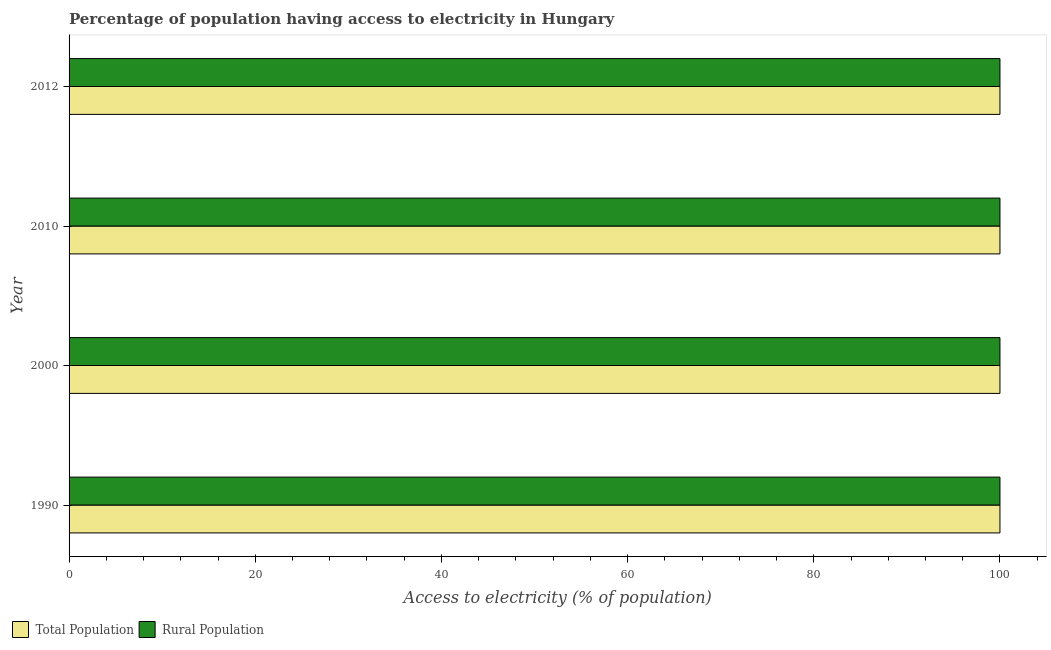How many different coloured bars are there?
Keep it short and to the point. 2. Are the number of bars on each tick of the Y-axis equal?
Offer a very short reply. Yes. How many bars are there on the 1st tick from the top?
Provide a short and direct response. 2. How many bars are there on the 2nd tick from the bottom?
Your answer should be compact. 2. What is the percentage of rural population having access to electricity in 2012?
Your answer should be very brief. 100. Across all years, what is the maximum percentage of population having access to electricity?
Provide a short and direct response. 100. Across all years, what is the minimum percentage of rural population having access to electricity?
Offer a very short reply. 100. In which year was the percentage of rural population having access to electricity maximum?
Your response must be concise. 1990. In which year was the percentage of rural population having access to electricity minimum?
Offer a very short reply. 1990. What is the total percentage of rural population having access to electricity in the graph?
Your answer should be very brief. 400. What is the difference between the percentage of rural population having access to electricity in 2010 and that in 2012?
Your answer should be very brief. 0. What is the difference between the percentage of population having access to electricity in 2010 and the percentage of rural population having access to electricity in 1990?
Provide a succinct answer. 0. What is the average percentage of rural population having access to electricity per year?
Offer a very short reply. 100. In the year 2012, what is the difference between the percentage of population having access to electricity and percentage of rural population having access to electricity?
Offer a very short reply. 0. What is the ratio of the percentage of rural population having access to electricity in 2000 to that in 2012?
Offer a terse response. 1. Is the difference between the percentage of population having access to electricity in 2010 and 2012 greater than the difference between the percentage of rural population having access to electricity in 2010 and 2012?
Make the answer very short. No. In how many years, is the percentage of population having access to electricity greater than the average percentage of population having access to electricity taken over all years?
Offer a very short reply. 0. What does the 2nd bar from the top in 2012 represents?
Keep it short and to the point. Total Population. What does the 2nd bar from the bottom in 2012 represents?
Give a very brief answer. Rural Population. How many bars are there?
Keep it short and to the point. 8. Are all the bars in the graph horizontal?
Keep it short and to the point. Yes. How many years are there in the graph?
Provide a succinct answer. 4. What is the difference between two consecutive major ticks on the X-axis?
Offer a very short reply. 20. Does the graph contain grids?
Keep it short and to the point. No. How are the legend labels stacked?
Offer a terse response. Horizontal. What is the title of the graph?
Keep it short and to the point. Percentage of population having access to electricity in Hungary. Does "Urban" appear as one of the legend labels in the graph?
Your answer should be very brief. No. What is the label or title of the X-axis?
Your answer should be very brief. Access to electricity (% of population). What is the Access to electricity (% of population) of Total Population in 1990?
Your answer should be very brief. 100. What is the Access to electricity (% of population) in Rural Population in 2000?
Provide a succinct answer. 100. What is the Access to electricity (% of population) of Rural Population in 2010?
Your answer should be compact. 100. What is the Access to electricity (% of population) in Total Population in 2012?
Provide a succinct answer. 100. Across all years, what is the maximum Access to electricity (% of population) of Total Population?
Your response must be concise. 100. Across all years, what is the maximum Access to electricity (% of population) of Rural Population?
Make the answer very short. 100. Across all years, what is the minimum Access to electricity (% of population) of Total Population?
Offer a terse response. 100. Across all years, what is the minimum Access to electricity (% of population) of Rural Population?
Provide a short and direct response. 100. What is the total Access to electricity (% of population) in Total Population in the graph?
Provide a short and direct response. 400. What is the total Access to electricity (% of population) of Rural Population in the graph?
Keep it short and to the point. 400. What is the difference between the Access to electricity (% of population) of Total Population in 1990 and that in 2000?
Provide a short and direct response. 0. What is the difference between the Access to electricity (% of population) in Total Population in 1990 and that in 2010?
Offer a very short reply. 0. What is the difference between the Access to electricity (% of population) of Total Population in 1990 and that in 2012?
Offer a very short reply. 0. What is the difference between the Access to electricity (% of population) in Total Population in 2000 and that in 2012?
Your response must be concise. 0. What is the difference between the Access to electricity (% of population) of Rural Population in 2000 and that in 2012?
Keep it short and to the point. 0. What is the difference between the Access to electricity (% of population) of Total Population in 1990 and the Access to electricity (% of population) of Rural Population in 2000?
Provide a short and direct response. 0. What is the difference between the Access to electricity (% of population) in Total Population in 1990 and the Access to electricity (% of population) in Rural Population in 2010?
Your response must be concise. 0. What is the average Access to electricity (% of population) of Total Population per year?
Your answer should be compact. 100. In the year 1990, what is the difference between the Access to electricity (% of population) of Total Population and Access to electricity (% of population) of Rural Population?
Offer a very short reply. 0. In the year 2010, what is the difference between the Access to electricity (% of population) of Total Population and Access to electricity (% of population) of Rural Population?
Your answer should be very brief. 0. In the year 2012, what is the difference between the Access to electricity (% of population) of Total Population and Access to electricity (% of population) of Rural Population?
Keep it short and to the point. 0. What is the ratio of the Access to electricity (% of population) of Total Population in 1990 to that in 2000?
Your answer should be compact. 1. What is the ratio of the Access to electricity (% of population) of Rural Population in 1990 to that in 2000?
Make the answer very short. 1. What is the ratio of the Access to electricity (% of population) in Total Population in 2000 to that in 2010?
Provide a short and direct response. 1. What is the ratio of the Access to electricity (% of population) of Total Population in 2000 to that in 2012?
Your response must be concise. 1. What is the ratio of the Access to electricity (% of population) of Rural Population in 2000 to that in 2012?
Your answer should be very brief. 1. What is the ratio of the Access to electricity (% of population) in Rural Population in 2010 to that in 2012?
Your answer should be compact. 1. What is the difference between the highest and the second highest Access to electricity (% of population) of Total Population?
Your answer should be compact. 0. What is the difference between the highest and the lowest Access to electricity (% of population) in Total Population?
Your answer should be very brief. 0. What is the difference between the highest and the lowest Access to electricity (% of population) of Rural Population?
Your response must be concise. 0. 